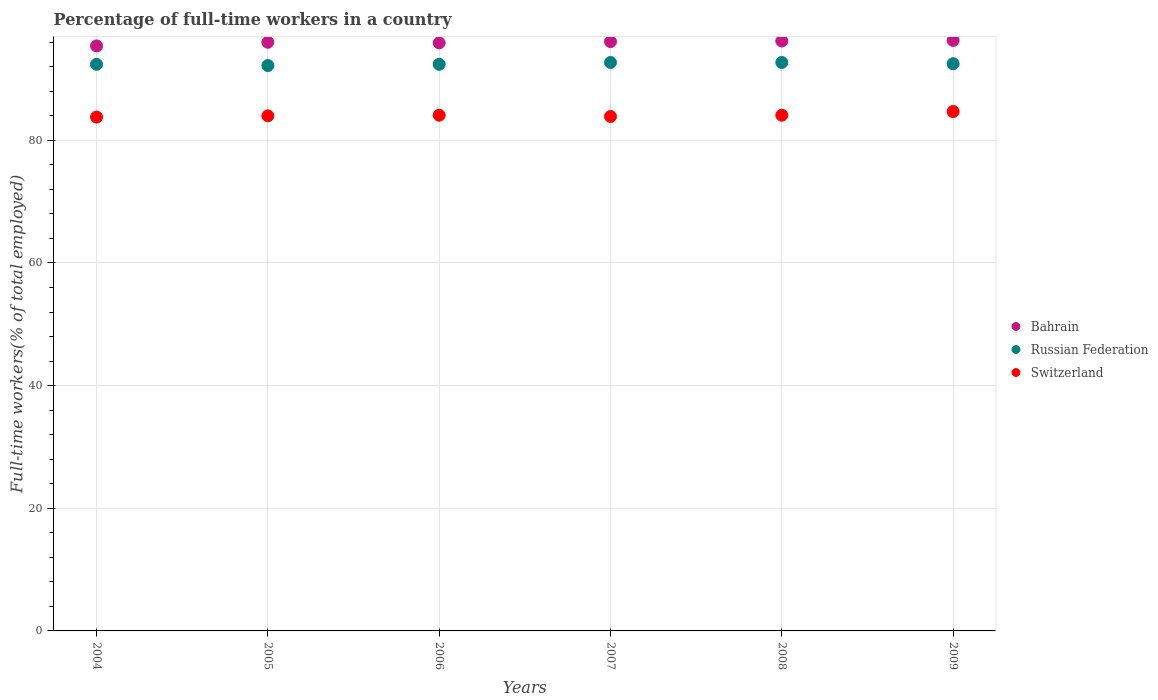What is the percentage of full-time workers in Russian Federation in 2005?
Provide a short and direct response. 92.2. Across all years, what is the maximum percentage of full-time workers in Switzerland?
Give a very brief answer. 84.7. Across all years, what is the minimum percentage of full-time workers in Switzerland?
Provide a succinct answer. 83.8. In which year was the percentage of full-time workers in Switzerland maximum?
Your answer should be very brief. 2009. In which year was the percentage of full-time workers in Switzerland minimum?
Offer a very short reply. 2004. What is the total percentage of full-time workers in Bahrain in the graph?
Your answer should be compact. 575.9. What is the difference between the percentage of full-time workers in Bahrain in 2004 and that in 2006?
Keep it short and to the point. -0.5. What is the difference between the percentage of full-time workers in Russian Federation in 2006 and the percentage of full-time workers in Bahrain in 2007?
Your answer should be very brief. -3.7. What is the average percentage of full-time workers in Bahrain per year?
Ensure brevity in your answer.  95.98. In the year 2005, what is the difference between the percentage of full-time workers in Russian Federation and percentage of full-time workers in Bahrain?
Offer a very short reply. -3.8. In how many years, is the percentage of full-time workers in Russian Federation greater than 52 %?
Your response must be concise. 6. What is the ratio of the percentage of full-time workers in Bahrain in 2004 to that in 2006?
Provide a short and direct response. 0.99. Is the percentage of full-time workers in Switzerland in 2007 less than that in 2009?
Keep it short and to the point. Yes. What is the difference between the highest and the second highest percentage of full-time workers in Russian Federation?
Give a very brief answer. 0. What is the difference between the highest and the lowest percentage of full-time workers in Switzerland?
Keep it short and to the point. 0.9. In how many years, is the percentage of full-time workers in Russian Federation greater than the average percentage of full-time workers in Russian Federation taken over all years?
Offer a very short reply. 3. Does the percentage of full-time workers in Russian Federation monotonically increase over the years?
Provide a short and direct response. No. Is the percentage of full-time workers in Russian Federation strictly less than the percentage of full-time workers in Bahrain over the years?
Your answer should be very brief. Yes. How many dotlines are there?
Provide a short and direct response. 3. How many years are there in the graph?
Offer a terse response. 6. What is the difference between two consecutive major ticks on the Y-axis?
Make the answer very short. 20. Are the values on the major ticks of Y-axis written in scientific E-notation?
Make the answer very short. No. Does the graph contain any zero values?
Give a very brief answer. No. Where does the legend appear in the graph?
Provide a succinct answer. Center right. How many legend labels are there?
Make the answer very short. 3. How are the legend labels stacked?
Offer a very short reply. Vertical. What is the title of the graph?
Your answer should be compact. Percentage of full-time workers in a country. What is the label or title of the Y-axis?
Give a very brief answer. Full-time workers(% of total employed). What is the Full-time workers(% of total employed) in Bahrain in 2004?
Your response must be concise. 95.4. What is the Full-time workers(% of total employed) of Russian Federation in 2004?
Your answer should be very brief. 92.4. What is the Full-time workers(% of total employed) in Switzerland in 2004?
Make the answer very short. 83.8. What is the Full-time workers(% of total employed) of Bahrain in 2005?
Provide a short and direct response. 96. What is the Full-time workers(% of total employed) in Russian Federation in 2005?
Provide a succinct answer. 92.2. What is the Full-time workers(% of total employed) of Switzerland in 2005?
Your answer should be very brief. 84. What is the Full-time workers(% of total employed) of Bahrain in 2006?
Provide a short and direct response. 95.9. What is the Full-time workers(% of total employed) in Russian Federation in 2006?
Offer a terse response. 92.4. What is the Full-time workers(% of total employed) of Switzerland in 2006?
Make the answer very short. 84.1. What is the Full-time workers(% of total employed) in Bahrain in 2007?
Your response must be concise. 96.1. What is the Full-time workers(% of total employed) in Russian Federation in 2007?
Give a very brief answer. 92.7. What is the Full-time workers(% of total employed) in Switzerland in 2007?
Provide a succinct answer. 83.9. What is the Full-time workers(% of total employed) in Bahrain in 2008?
Your response must be concise. 96.2. What is the Full-time workers(% of total employed) of Russian Federation in 2008?
Your answer should be very brief. 92.7. What is the Full-time workers(% of total employed) in Switzerland in 2008?
Offer a terse response. 84.1. What is the Full-time workers(% of total employed) in Bahrain in 2009?
Keep it short and to the point. 96.3. What is the Full-time workers(% of total employed) of Russian Federation in 2009?
Make the answer very short. 92.5. What is the Full-time workers(% of total employed) in Switzerland in 2009?
Your answer should be compact. 84.7. Across all years, what is the maximum Full-time workers(% of total employed) in Bahrain?
Provide a succinct answer. 96.3. Across all years, what is the maximum Full-time workers(% of total employed) of Russian Federation?
Your answer should be very brief. 92.7. Across all years, what is the maximum Full-time workers(% of total employed) in Switzerland?
Give a very brief answer. 84.7. Across all years, what is the minimum Full-time workers(% of total employed) in Bahrain?
Offer a very short reply. 95.4. Across all years, what is the minimum Full-time workers(% of total employed) in Russian Federation?
Make the answer very short. 92.2. Across all years, what is the minimum Full-time workers(% of total employed) of Switzerland?
Provide a short and direct response. 83.8. What is the total Full-time workers(% of total employed) in Bahrain in the graph?
Offer a terse response. 575.9. What is the total Full-time workers(% of total employed) in Russian Federation in the graph?
Give a very brief answer. 554.9. What is the total Full-time workers(% of total employed) in Switzerland in the graph?
Provide a succinct answer. 504.6. What is the difference between the Full-time workers(% of total employed) in Bahrain in 2004 and that in 2005?
Your answer should be very brief. -0.6. What is the difference between the Full-time workers(% of total employed) in Switzerland in 2004 and that in 2005?
Offer a terse response. -0.2. What is the difference between the Full-time workers(% of total employed) of Bahrain in 2004 and that in 2006?
Your answer should be compact. -0.5. What is the difference between the Full-time workers(% of total employed) in Russian Federation in 2004 and that in 2007?
Offer a very short reply. -0.3. What is the difference between the Full-time workers(% of total employed) of Switzerland in 2004 and that in 2007?
Ensure brevity in your answer.  -0.1. What is the difference between the Full-time workers(% of total employed) in Bahrain in 2004 and that in 2008?
Make the answer very short. -0.8. What is the difference between the Full-time workers(% of total employed) in Bahrain in 2005 and that in 2006?
Provide a succinct answer. 0.1. What is the difference between the Full-time workers(% of total employed) in Bahrain in 2005 and that in 2007?
Make the answer very short. -0.1. What is the difference between the Full-time workers(% of total employed) in Russian Federation in 2005 and that in 2007?
Your answer should be compact. -0.5. What is the difference between the Full-time workers(% of total employed) in Switzerland in 2005 and that in 2007?
Your answer should be compact. 0.1. What is the difference between the Full-time workers(% of total employed) of Bahrain in 2005 and that in 2008?
Offer a terse response. -0.2. What is the difference between the Full-time workers(% of total employed) of Russian Federation in 2005 and that in 2008?
Give a very brief answer. -0.5. What is the difference between the Full-time workers(% of total employed) in Switzerland in 2005 and that in 2008?
Provide a succinct answer. -0.1. What is the difference between the Full-time workers(% of total employed) of Russian Federation in 2005 and that in 2009?
Make the answer very short. -0.3. What is the difference between the Full-time workers(% of total employed) in Russian Federation in 2006 and that in 2008?
Your answer should be very brief. -0.3. What is the difference between the Full-time workers(% of total employed) in Switzerland in 2006 and that in 2009?
Your response must be concise. -0.6. What is the difference between the Full-time workers(% of total employed) in Bahrain in 2007 and that in 2008?
Ensure brevity in your answer.  -0.1. What is the difference between the Full-time workers(% of total employed) in Russian Federation in 2007 and that in 2008?
Provide a succinct answer. 0. What is the difference between the Full-time workers(% of total employed) in Bahrain in 2007 and that in 2009?
Give a very brief answer. -0.2. What is the difference between the Full-time workers(% of total employed) in Switzerland in 2007 and that in 2009?
Ensure brevity in your answer.  -0.8. What is the difference between the Full-time workers(% of total employed) of Bahrain in 2004 and the Full-time workers(% of total employed) of Russian Federation in 2005?
Offer a very short reply. 3.2. What is the difference between the Full-time workers(% of total employed) of Bahrain in 2004 and the Full-time workers(% of total employed) of Russian Federation in 2006?
Your response must be concise. 3. What is the difference between the Full-time workers(% of total employed) of Bahrain in 2004 and the Full-time workers(% of total employed) of Switzerland in 2006?
Give a very brief answer. 11.3. What is the difference between the Full-time workers(% of total employed) in Bahrain in 2004 and the Full-time workers(% of total employed) in Russian Federation in 2007?
Your answer should be very brief. 2.7. What is the difference between the Full-time workers(% of total employed) in Bahrain in 2004 and the Full-time workers(% of total employed) in Switzerland in 2007?
Your response must be concise. 11.5. What is the difference between the Full-time workers(% of total employed) of Russian Federation in 2004 and the Full-time workers(% of total employed) of Switzerland in 2007?
Keep it short and to the point. 8.5. What is the difference between the Full-time workers(% of total employed) in Bahrain in 2004 and the Full-time workers(% of total employed) in Switzerland in 2008?
Your answer should be compact. 11.3. What is the difference between the Full-time workers(% of total employed) of Russian Federation in 2004 and the Full-time workers(% of total employed) of Switzerland in 2008?
Your response must be concise. 8.3. What is the difference between the Full-time workers(% of total employed) of Bahrain in 2004 and the Full-time workers(% of total employed) of Russian Federation in 2009?
Offer a terse response. 2.9. What is the difference between the Full-time workers(% of total employed) of Bahrain in 2004 and the Full-time workers(% of total employed) of Switzerland in 2009?
Offer a very short reply. 10.7. What is the difference between the Full-time workers(% of total employed) of Russian Federation in 2004 and the Full-time workers(% of total employed) of Switzerland in 2009?
Your response must be concise. 7.7. What is the difference between the Full-time workers(% of total employed) in Bahrain in 2005 and the Full-time workers(% of total employed) in Russian Federation in 2006?
Your answer should be compact. 3.6. What is the difference between the Full-time workers(% of total employed) of Bahrain in 2005 and the Full-time workers(% of total employed) of Switzerland in 2006?
Give a very brief answer. 11.9. What is the difference between the Full-time workers(% of total employed) in Russian Federation in 2005 and the Full-time workers(% of total employed) in Switzerland in 2006?
Give a very brief answer. 8.1. What is the difference between the Full-time workers(% of total employed) in Bahrain in 2005 and the Full-time workers(% of total employed) in Switzerland in 2007?
Your answer should be very brief. 12.1. What is the difference between the Full-time workers(% of total employed) of Bahrain in 2005 and the Full-time workers(% of total employed) of Russian Federation in 2008?
Keep it short and to the point. 3.3. What is the difference between the Full-time workers(% of total employed) in Bahrain in 2005 and the Full-time workers(% of total employed) in Switzerland in 2008?
Offer a terse response. 11.9. What is the difference between the Full-time workers(% of total employed) of Bahrain in 2005 and the Full-time workers(% of total employed) of Russian Federation in 2009?
Provide a short and direct response. 3.5. What is the difference between the Full-time workers(% of total employed) in Bahrain in 2006 and the Full-time workers(% of total employed) in Russian Federation in 2007?
Provide a short and direct response. 3.2. What is the difference between the Full-time workers(% of total employed) in Bahrain in 2006 and the Full-time workers(% of total employed) in Switzerland in 2007?
Offer a very short reply. 12. What is the difference between the Full-time workers(% of total employed) in Bahrain in 2006 and the Full-time workers(% of total employed) in Switzerland in 2008?
Keep it short and to the point. 11.8. What is the difference between the Full-time workers(% of total employed) in Russian Federation in 2006 and the Full-time workers(% of total employed) in Switzerland in 2008?
Offer a terse response. 8.3. What is the difference between the Full-time workers(% of total employed) of Bahrain in 2006 and the Full-time workers(% of total employed) of Switzerland in 2009?
Your response must be concise. 11.2. What is the difference between the Full-time workers(% of total employed) of Russian Federation in 2007 and the Full-time workers(% of total employed) of Switzerland in 2008?
Give a very brief answer. 8.6. What is the difference between the Full-time workers(% of total employed) in Bahrain in 2007 and the Full-time workers(% of total employed) in Russian Federation in 2009?
Your response must be concise. 3.6. What is the difference between the Full-time workers(% of total employed) in Bahrain in 2007 and the Full-time workers(% of total employed) in Switzerland in 2009?
Provide a succinct answer. 11.4. What is the difference between the Full-time workers(% of total employed) of Russian Federation in 2007 and the Full-time workers(% of total employed) of Switzerland in 2009?
Provide a succinct answer. 8. What is the difference between the Full-time workers(% of total employed) in Bahrain in 2008 and the Full-time workers(% of total employed) in Switzerland in 2009?
Offer a very short reply. 11.5. What is the average Full-time workers(% of total employed) of Bahrain per year?
Keep it short and to the point. 95.98. What is the average Full-time workers(% of total employed) in Russian Federation per year?
Make the answer very short. 92.48. What is the average Full-time workers(% of total employed) of Switzerland per year?
Provide a succinct answer. 84.1. In the year 2004, what is the difference between the Full-time workers(% of total employed) in Bahrain and Full-time workers(% of total employed) in Russian Federation?
Offer a terse response. 3. In the year 2004, what is the difference between the Full-time workers(% of total employed) of Russian Federation and Full-time workers(% of total employed) of Switzerland?
Your answer should be very brief. 8.6. In the year 2006, what is the difference between the Full-time workers(% of total employed) in Bahrain and Full-time workers(% of total employed) in Russian Federation?
Your response must be concise. 3.5. In the year 2006, what is the difference between the Full-time workers(% of total employed) of Bahrain and Full-time workers(% of total employed) of Switzerland?
Provide a succinct answer. 11.8. In the year 2006, what is the difference between the Full-time workers(% of total employed) of Russian Federation and Full-time workers(% of total employed) of Switzerland?
Your response must be concise. 8.3. In the year 2007, what is the difference between the Full-time workers(% of total employed) of Bahrain and Full-time workers(% of total employed) of Russian Federation?
Your response must be concise. 3.4. In the year 2008, what is the difference between the Full-time workers(% of total employed) in Bahrain and Full-time workers(% of total employed) in Switzerland?
Your answer should be compact. 12.1. In the year 2009, what is the difference between the Full-time workers(% of total employed) in Bahrain and Full-time workers(% of total employed) in Switzerland?
Keep it short and to the point. 11.6. What is the ratio of the Full-time workers(% of total employed) of Bahrain in 2004 to that in 2005?
Make the answer very short. 0.99. What is the ratio of the Full-time workers(% of total employed) of Bahrain in 2004 to that in 2006?
Give a very brief answer. 0.99. What is the ratio of the Full-time workers(% of total employed) in Russian Federation in 2004 to that in 2006?
Give a very brief answer. 1. What is the ratio of the Full-time workers(% of total employed) of Russian Federation in 2004 to that in 2007?
Keep it short and to the point. 1. What is the ratio of the Full-time workers(% of total employed) of Bahrain in 2005 to that in 2007?
Your answer should be very brief. 1. What is the ratio of the Full-time workers(% of total employed) of Russian Federation in 2005 to that in 2007?
Make the answer very short. 0.99. What is the ratio of the Full-time workers(% of total employed) in Switzerland in 2005 to that in 2007?
Provide a succinct answer. 1. What is the ratio of the Full-time workers(% of total employed) in Switzerland in 2005 to that in 2008?
Your answer should be very brief. 1. What is the ratio of the Full-time workers(% of total employed) of Bahrain in 2005 to that in 2009?
Make the answer very short. 1. What is the ratio of the Full-time workers(% of total employed) of Switzerland in 2005 to that in 2009?
Your answer should be compact. 0.99. What is the ratio of the Full-time workers(% of total employed) of Bahrain in 2006 to that in 2007?
Ensure brevity in your answer.  1. What is the ratio of the Full-time workers(% of total employed) in Russian Federation in 2006 to that in 2007?
Offer a very short reply. 1. What is the ratio of the Full-time workers(% of total employed) of Switzerland in 2006 to that in 2008?
Make the answer very short. 1. What is the ratio of the Full-time workers(% of total employed) in Russian Federation in 2006 to that in 2009?
Give a very brief answer. 1. What is the ratio of the Full-time workers(% of total employed) of Switzerland in 2006 to that in 2009?
Give a very brief answer. 0.99. What is the ratio of the Full-time workers(% of total employed) of Switzerland in 2007 to that in 2008?
Give a very brief answer. 1. What is the ratio of the Full-time workers(% of total employed) of Bahrain in 2007 to that in 2009?
Your answer should be very brief. 1. What is the ratio of the Full-time workers(% of total employed) in Russian Federation in 2007 to that in 2009?
Give a very brief answer. 1. What is the ratio of the Full-time workers(% of total employed) in Switzerland in 2007 to that in 2009?
Make the answer very short. 0.99. What is the difference between the highest and the second highest Full-time workers(% of total employed) of Russian Federation?
Provide a succinct answer. 0. 